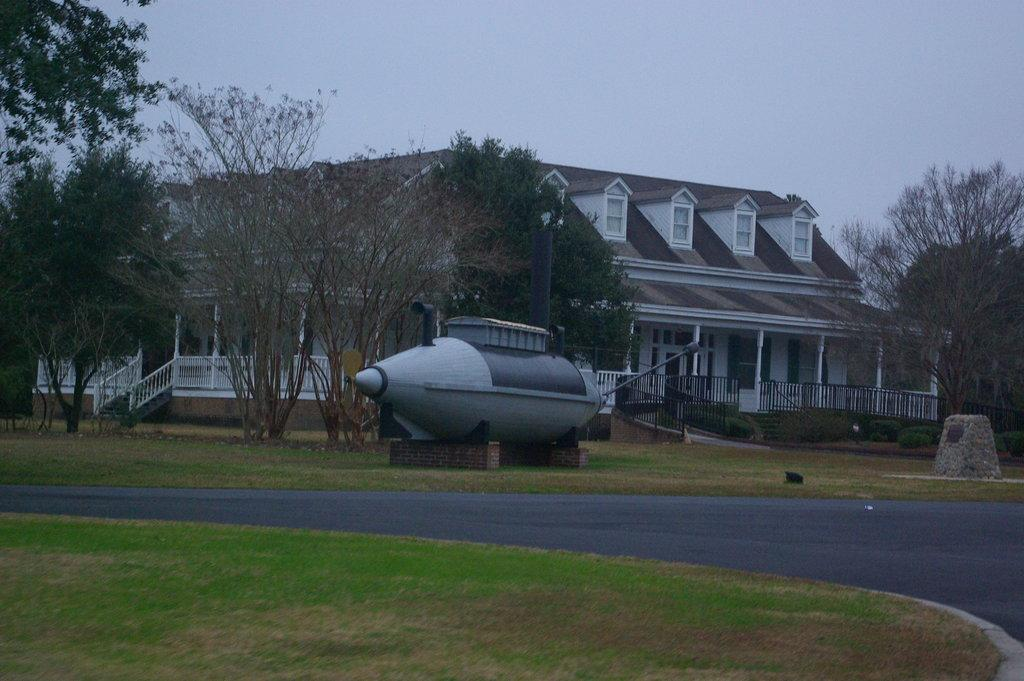What is located in the middle of the image? There is a road in the middle of the image. What object with a unique shape can be seen in the image? There is an object in the shape of a ship in the image. What type of natural vegetation is visible in the background of the image? There are trees in the background of the image. What type of structure is visible in the background of the image? There is a house in the background of the image. What is visible at the top of the image? The sky is visible at the top of the image. Can you tell me how many stomachs are visible in the image? There are no stomachs present in the image. Is there a crown on top of the house in the image? There is no crown present in the image; only the house and other objects are visible. 